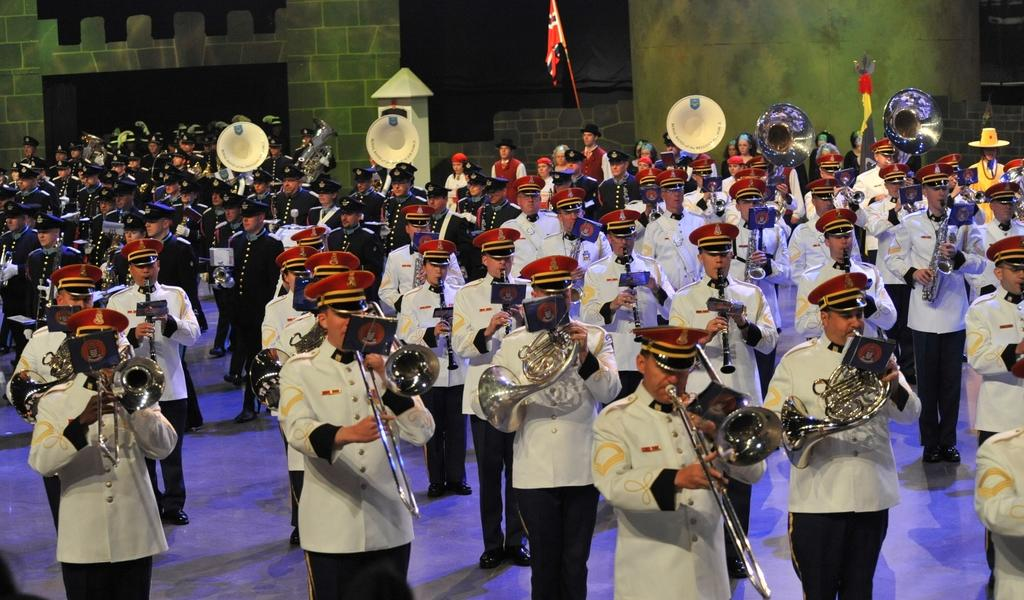What are the people in the image doing? The people in the image are holding musical instruments. What is visible beneath the people's feet in the image? There is ground visible in the image. What can be seen behind the people in the image? There is a background in the image. What type of decoration or symbol can be seen in the image? Flags are present in the image. What type of body is visible in the image? There is no specific body visible in the image; it features people holding musical instruments. What type of loss is being experienced by the people in the image? There is no indication of loss in the image; the people are holding musical instruments and may be performing or practicing. 